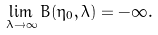<formula> <loc_0><loc_0><loc_500><loc_500>\lim _ { \lambda \to \infty } B ( \eta _ { 0 } , \lambda ) = - \infty .</formula> 